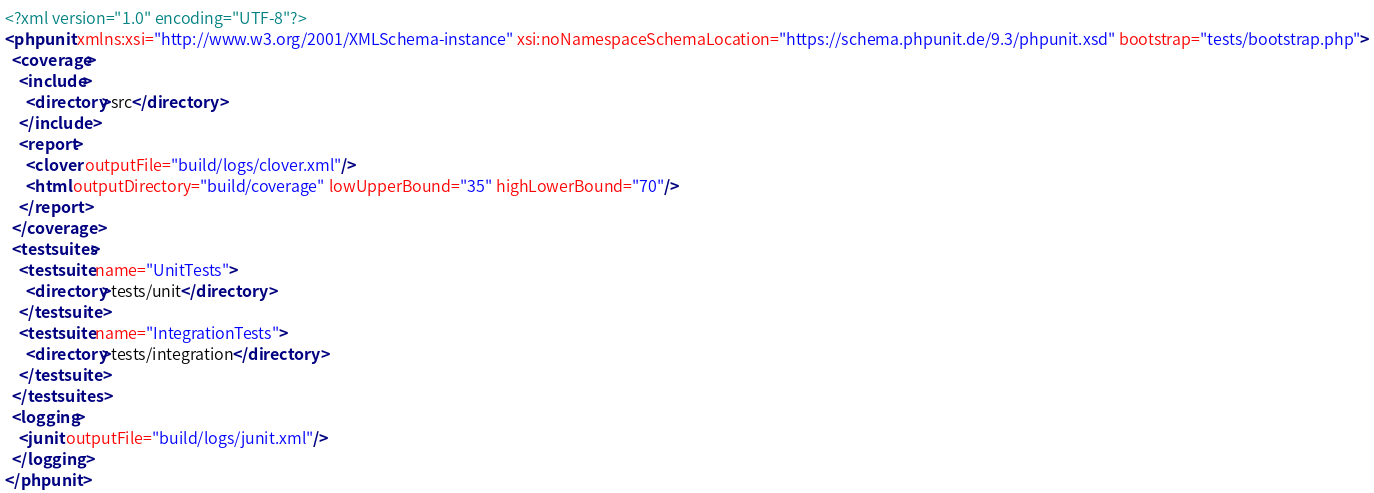<code> <loc_0><loc_0><loc_500><loc_500><_XML_><?xml version="1.0" encoding="UTF-8"?>
<phpunit xmlns:xsi="http://www.w3.org/2001/XMLSchema-instance" xsi:noNamespaceSchemaLocation="https://schema.phpunit.de/9.3/phpunit.xsd" bootstrap="tests/bootstrap.php">
  <coverage>
    <include>
      <directory>src</directory>
    </include>
    <report>
      <clover outputFile="build/logs/clover.xml"/>
      <html outputDirectory="build/coverage" lowUpperBound="35" highLowerBound="70"/>
    </report>
  </coverage>
  <testsuites>
    <testsuite name="UnitTests">
      <directory>tests/unit</directory>
    </testsuite>
    <testsuite name="IntegrationTests">
      <directory>tests/integration</directory>
    </testsuite>
  </testsuites>
  <logging>
    <junit outputFile="build/logs/junit.xml"/>
  </logging>
</phpunit>
</code> 